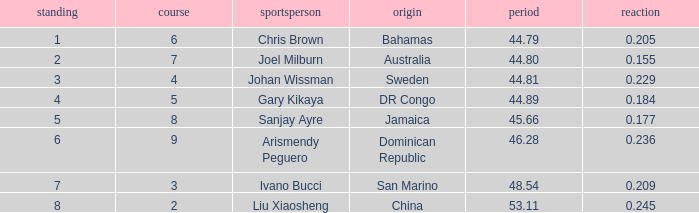How many total Time listings have a 0.209 React entry and a Rank that is greater than 7? 0.0. 